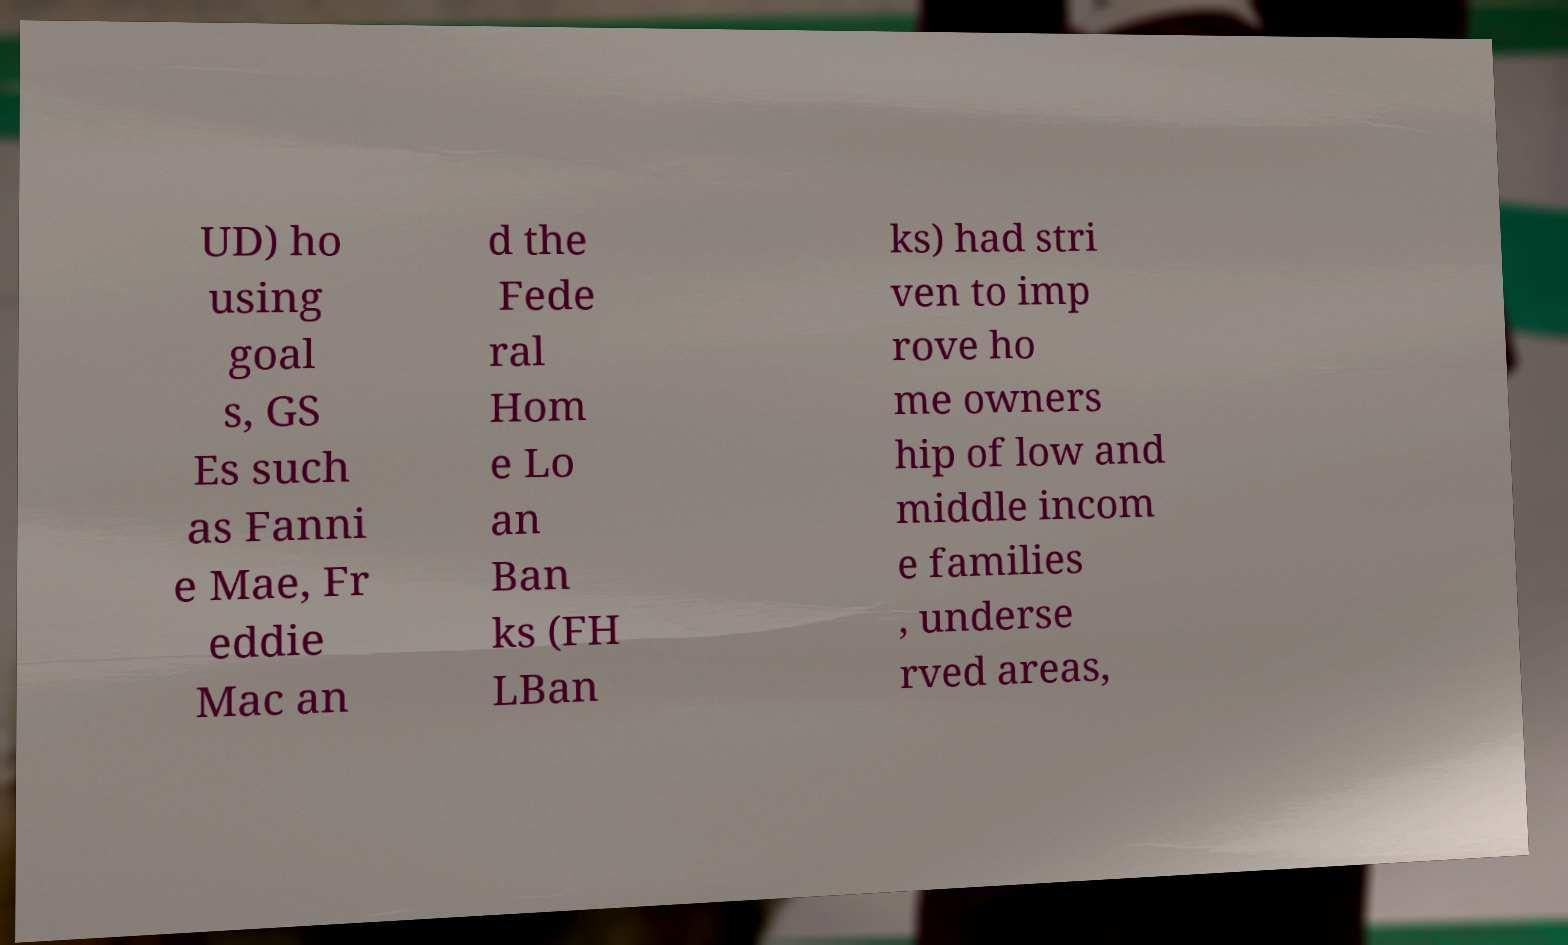Could you extract and type out the text from this image? UD) ho using goal s, GS Es such as Fanni e Mae, Fr eddie Mac an d the Fede ral Hom e Lo an Ban ks (FH LBan ks) had stri ven to imp rove ho me owners hip of low and middle incom e families , underse rved areas, 